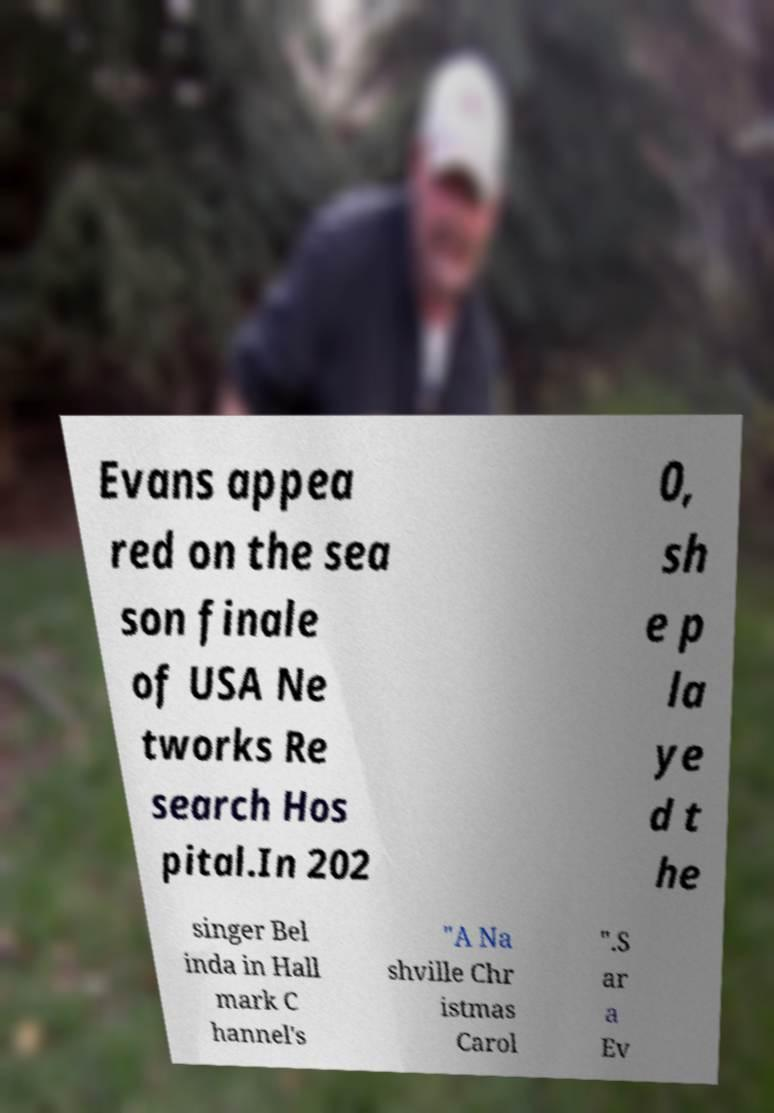I need the written content from this picture converted into text. Can you do that? Evans appea red on the sea son finale of USA Ne tworks Re search Hos pital.In 202 0, sh e p la ye d t he singer Bel inda in Hall mark C hannel's "A Na shville Chr istmas Carol ".S ar a Ev 